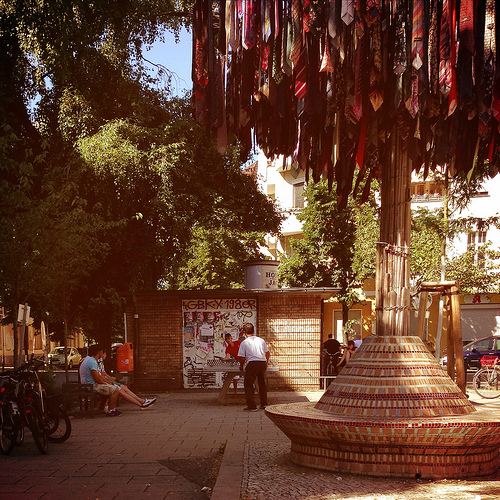<image>
Can you confirm if the bench is behind the guy? No. The bench is not behind the guy. From this viewpoint, the bench appears to be positioned elsewhere in the scene. Is there a neck ties above the ground? Yes. The neck ties is positioned above the ground in the vertical space, higher up in the scene. 